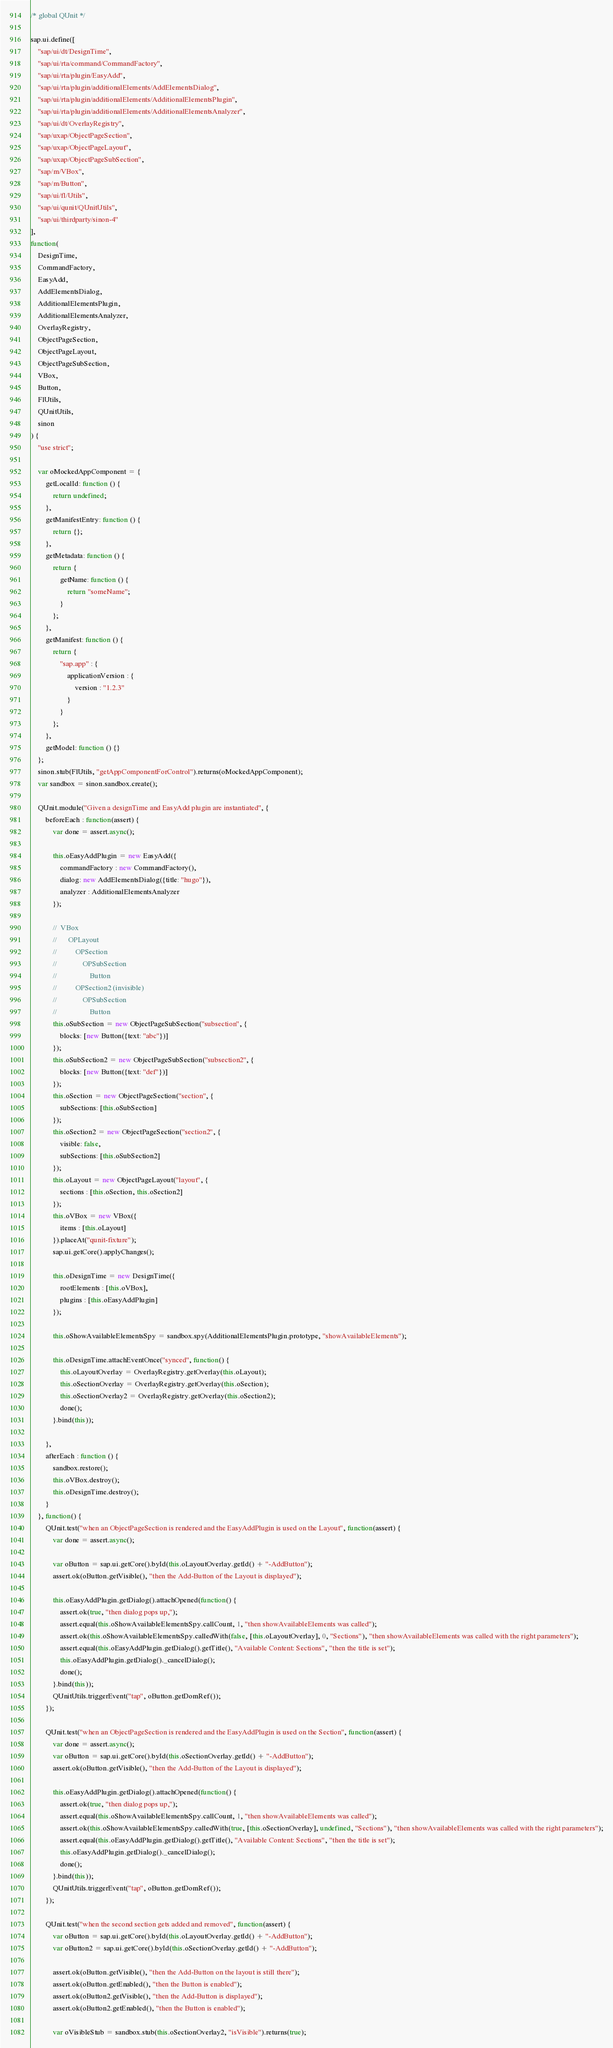<code> <loc_0><loc_0><loc_500><loc_500><_JavaScript_>/* global QUnit */

sap.ui.define([
	"sap/ui/dt/DesignTime",
	"sap/ui/rta/command/CommandFactory",
	"sap/ui/rta/plugin/EasyAdd",
	"sap/ui/rta/plugin/additionalElements/AddElementsDialog",
	"sap/ui/rta/plugin/additionalElements/AdditionalElementsPlugin",
	"sap/ui/rta/plugin/additionalElements/AdditionalElementsAnalyzer",
	"sap/ui/dt/OverlayRegistry",
	"sap/uxap/ObjectPageSection",
	"sap/uxap/ObjectPageLayout",
	"sap/uxap/ObjectPageSubSection",
	"sap/m/VBox",
	"sap/m/Button",
	"sap/ui/fl/Utils",
	"sap/ui/qunit/QUnitUtils",
	"sap/ui/thirdparty/sinon-4"
],
function(
	DesignTime,
	CommandFactory,
	EasyAdd,
	AddElementsDialog,
	AdditionalElementsPlugin,
	AdditionalElementsAnalyzer,
	OverlayRegistry,
	ObjectPageSection,
	ObjectPageLayout,
	ObjectPageSubSection,
	VBox,
	Button,
	FlUtils,
	QUnitUtils,
	sinon
) {
	"use strict";

	var oMockedAppComponent = {
		getLocalId: function () {
			return undefined;
		},
		getManifestEntry: function () {
			return {};
		},
		getMetadata: function () {
			return {
				getName: function () {
					return "someName";
				}
			};
		},
		getManifest: function () {
			return {
				"sap.app" : {
					applicationVersion : {
						version : "1.2.3"
					}
				}
			};
		},
		getModel: function () {}
	};
	sinon.stub(FlUtils, "getAppComponentForControl").returns(oMockedAppComponent);
	var sandbox = sinon.sandbox.create();

	QUnit.module("Given a designTime and EasyAdd plugin are instantiated", {
		beforeEach : function(assert) {
			var done = assert.async();

			this.oEasyAddPlugin = new EasyAdd({
				commandFactory : new CommandFactory(),
				dialog: new AddElementsDialog({title: "hugo"}),
				analyzer : AdditionalElementsAnalyzer
			});

			//	VBox
			//		OPLayout
			//			OPSection
			//				OPSubSection
			//					Button
			//			OPSection2 (invisible)
			//				OPSubSection
			//					Button
			this.oSubSection = new ObjectPageSubSection("subsection", {
				blocks: [new Button({text: "abc"})]
			});
			this.oSubSection2 = new ObjectPageSubSection("subsection2", {
				blocks: [new Button({text: "def"})]
			});
			this.oSection = new ObjectPageSection("section", {
				subSections: [this.oSubSection]
			});
			this.oSection2 = new ObjectPageSection("section2", {
				visible: false,
				subSections: [this.oSubSection2]
			});
			this.oLayout = new ObjectPageLayout("layout", {
				sections : [this.oSection, this.oSection2]
			});
			this.oVBox = new VBox({
				items : [this.oLayout]
			}).placeAt("qunit-fixture");
			sap.ui.getCore().applyChanges();

			this.oDesignTime = new DesignTime({
				rootElements : [this.oVBox],
				plugins : [this.oEasyAddPlugin]
			});

			this.oShowAvailableElementsSpy = sandbox.spy(AdditionalElementsPlugin.prototype, "showAvailableElements");

			this.oDesignTime.attachEventOnce("synced", function() {
				this.oLayoutOverlay = OverlayRegistry.getOverlay(this.oLayout);
				this.oSectionOverlay = OverlayRegistry.getOverlay(this.oSection);
				this.oSectionOverlay2 = OverlayRegistry.getOverlay(this.oSection2);
				done();
			}.bind(this));

		},
		afterEach : function () {
			sandbox.restore();
			this.oVBox.destroy();
			this.oDesignTime.destroy();
		}
	}, function() {
		QUnit.test("when an ObjectPageSection is rendered and the EasyAddPlugin is used on the Layout", function(assert) {
			var done = assert.async();

			var oButton = sap.ui.getCore().byId(this.oLayoutOverlay.getId() + "-AddButton");
			assert.ok(oButton.getVisible(), "then the Add-Button of the Layout is displayed");

			this.oEasyAddPlugin.getDialog().attachOpened(function() {
				assert.ok(true, "then dialog pops up,");
				assert.equal(this.oShowAvailableElementsSpy.callCount, 1, "then showAvailableElements was called");
				assert.ok(this.oShowAvailableElementsSpy.calledWith(false, [this.oLayoutOverlay], 0, "Sections"), "then showAvailableElements was called with the right parameters");
				assert.equal(this.oEasyAddPlugin.getDialog().getTitle(), "Available Content: Sections", "then the title is set");
				this.oEasyAddPlugin.getDialog()._cancelDialog();
				done();
			}.bind(this));
			QUnitUtils.triggerEvent("tap", oButton.getDomRef());
		});

		QUnit.test("when an ObjectPageSection is rendered and the EasyAddPlugin is used on the Section", function(assert) {
			var done = assert.async();
			var oButton = sap.ui.getCore().byId(this.oSectionOverlay.getId() + "-AddButton");
			assert.ok(oButton.getVisible(), "then the Add-Button of the Layout is displayed");

			this.oEasyAddPlugin.getDialog().attachOpened(function() {
				assert.ok(true, "then dialog pops up,");
				assert.equal(this.oShowAvailableElementsSpy.callCount, 1, "then showAvailableElements was called");
				assert.ok(this.oShowAvailableElementsSpy.calledWith(true, [this.oSectionOverlay], undefined, "Sections"), "then showAvailableElements was called with the right parameters");
				assert.equal(this.oEasyAddPlugin.getDialog().getTitle(), "Available Content: Sections", "then the title is set");
				this.oEasyAddPlugin.getDialog()._cancelDialog();
				done();
			}.bind(this));
			QUnitUtils.triggerEvent("tap", oButton.getDomRef());
		});

		QUnit.test("when the second section gets added and removed", function(assert) {
			var oButton = sap.ui.getCore().byId(this.oLayoutOverlay.getId() + "-AddButton");
			var oButton2 = sap.ui.getCore().byId(this.oSectionOverlay.getId() + "-AddButton");

			assert.ok(oButton.getVisible(), "then the Add-Button on the layout is still there");
			assert.ok(oButton.getEnabled(), "then the Button is enabled");
			assert.ok(oButton2.getVisible(), "then the Add-Button is displayed");
			assert.ok(oButton2.getEnabled(), "then the Button is enabled");

			var oVisibleStub = sandbox.stub(this.oSectionOverlay2, "isVisible").returns(true);</code> 